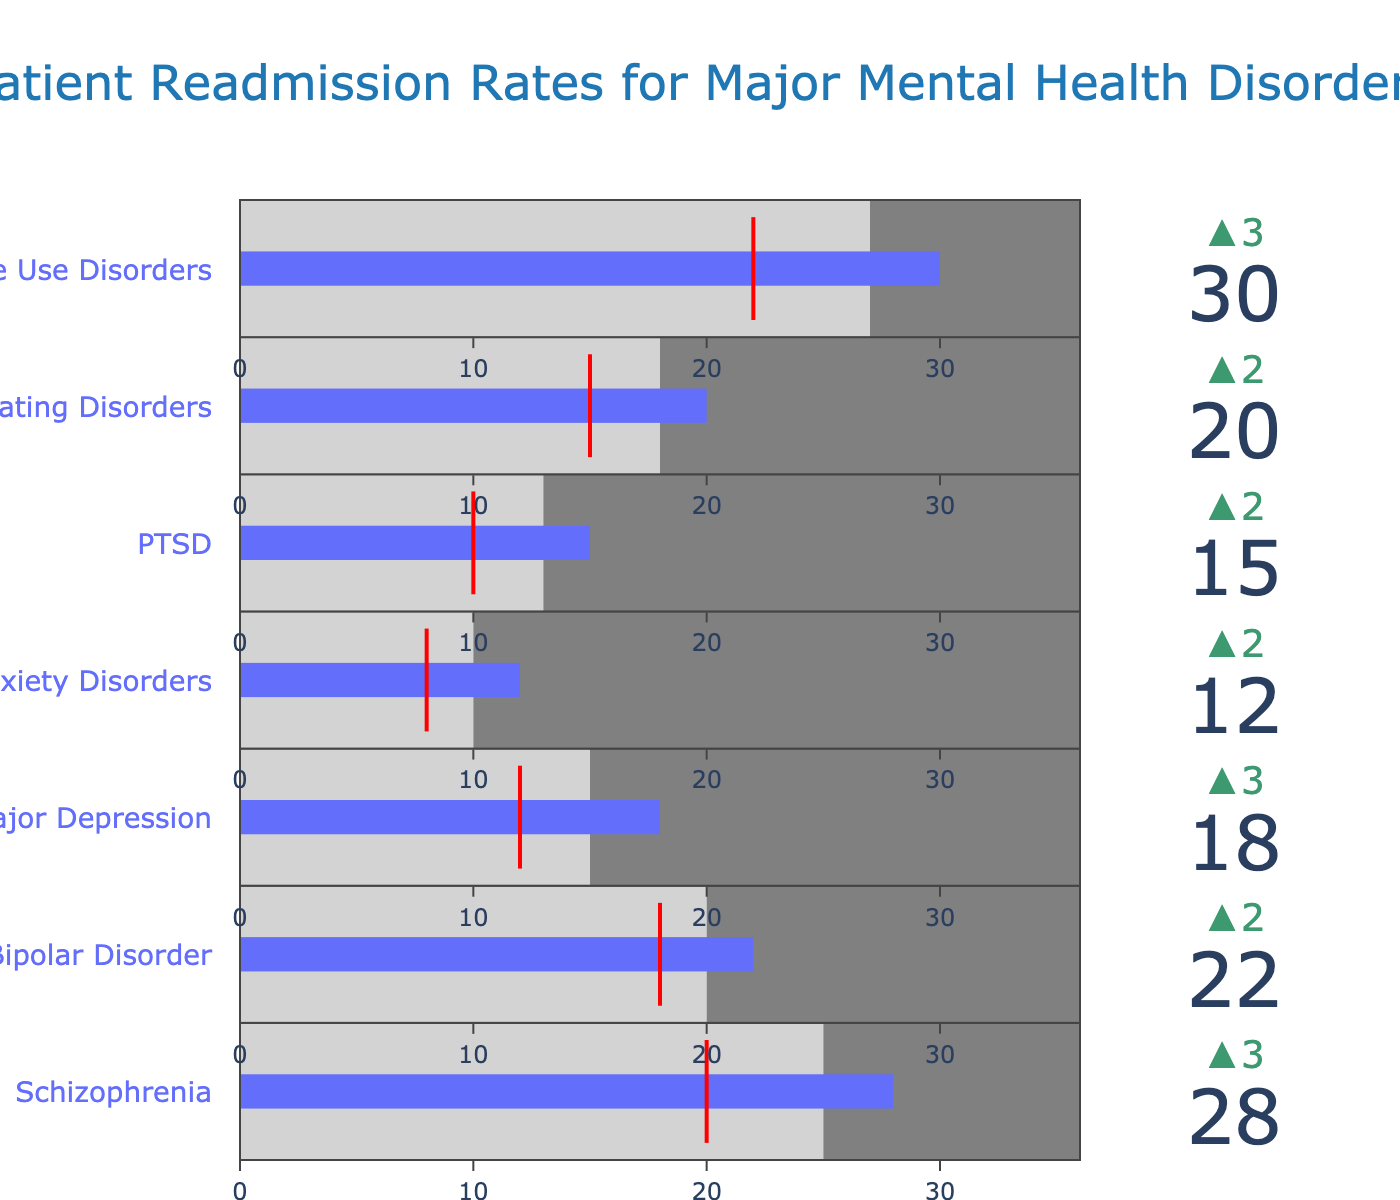What's the actual readmission rate for Schizophrenia? The actual readmission rate is visually indicated at the bullet center for Schizophrenia. It is labeled 28.
Answer: 28 What's the difference between the actual and benchmark readmission rates for Bipolar Disorder? First, identify the actual readmission rate, which is 22. Then, identify the benchmark readmission rate, which is 20. Subtract the benchmark from the actual: 22 - 20.
Answer: 2 Which mental health disorder has the highest benchmark readmission rate? Compare all the benchmark values to find the largest one. Substance Use Disorders has the highest benchmark readmission rate at 27.
Answer: Substance Use Disorders Does the actual readmission rate for Anxiety Disorders meet the target? Compare the actual readmission rate (12) with the target value (8). The actual rate is higher, so it does not meet the target.
Answer: No What is the visual indication for meeting or exceeding the target rate on the bullet chart? The threshold is indicated by a red line. If the actual rate (blue bar) exceeds the red line, it means the target is not met.
Answer: Red line Are there any disorders where the actual readmission rate is equal to the benchmark rate? Compare each disorder’s actual readmission rate with its benchmark rate. None of them have equal values.
Answer: No Which disorder has the smallest gap between actual and target readmission rates? Calculate the differences for each disorder:
Schizophrenia: 28 - 20 = 8
Bipolar Disorder: 22 - 18 = 4
Major Depression: 18 - 12 = 6
Anxiety Disorders: 12 - 8 = 4
PTSD: 15 - 10 = 5
Eating Disorders: 20 - 15 = 5
Substance Use Disorders: 30 - 22 = 8
Bipolar Disorder and Anxiety Disorders have the smallest gaps (both 4).
Answer: Bipolar Disorder and Anxiety Disorders What is the range of values on the axis for the bullet chart? The range is defined by the highest actual readmission rate plus buffer. The highest actual rate is 30, so the range goes up to approximately 30 * 1.2 = 36.
Answer: 0 to 36 